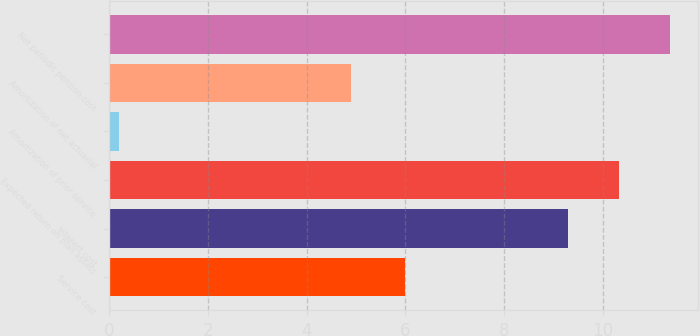<chart> <loc_0><loc_0><loc_500><loc_500><bar_chart><fcel>Service cost<fcel>Interest cost<fcel>Expected return on plan assets<fcel>Amortization of prior service<fcel>Amortization of net actuarial<fcel>Net periodic pension cost<nl><fcel>6<fcel>9.3<fcel>10.33<fcel>0.2<fcel>4.9<fcel>11.36<nl></chart> 